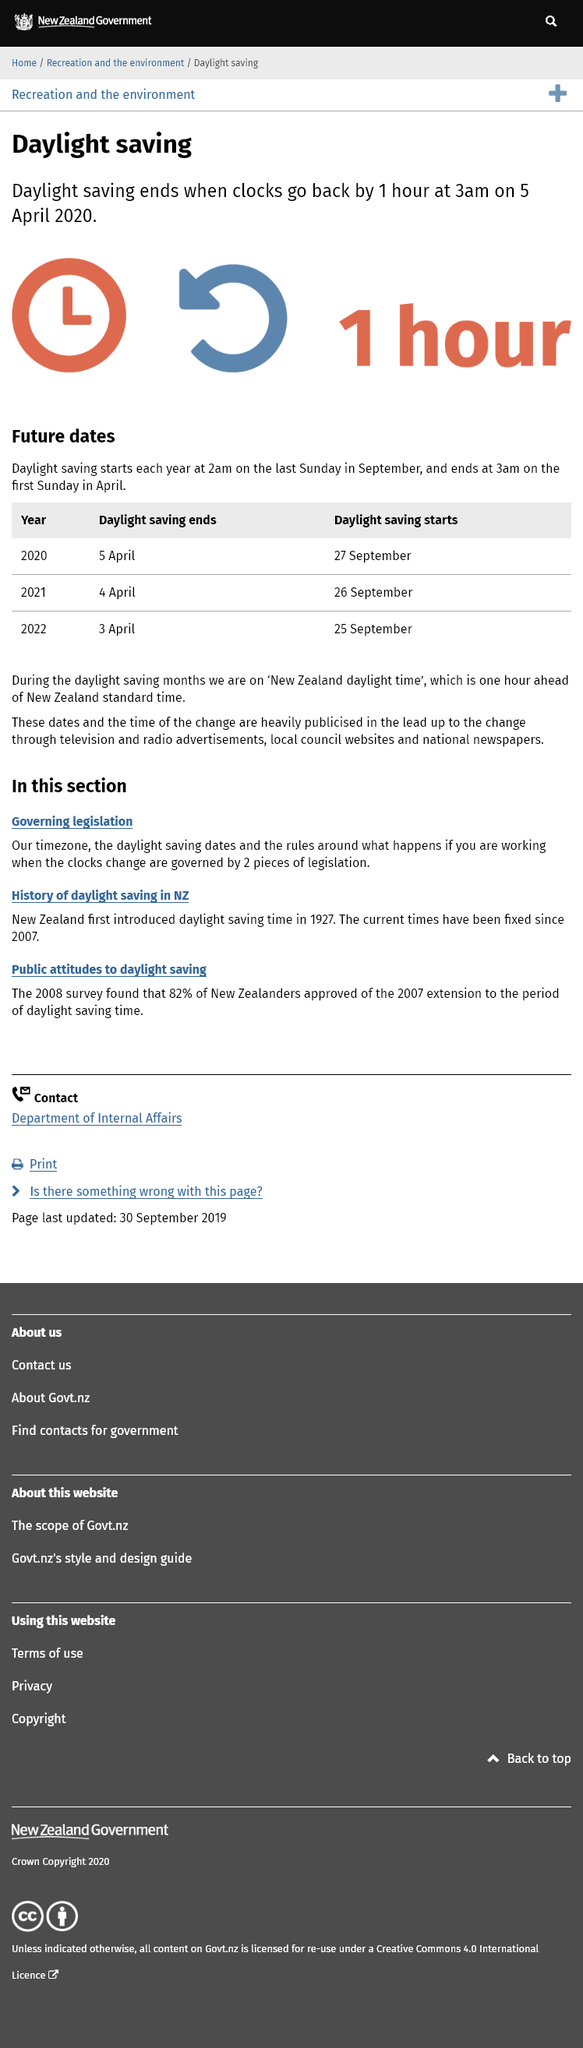Highlight a few significant elements in this photo. On September 26th, 2021, daylight savings will begin. On April 5th, 2020, daylight saving will end at 3:00 a.m. On April 3rd, 2022, the daylight savings period will come to an end, marking the return to standard time. 